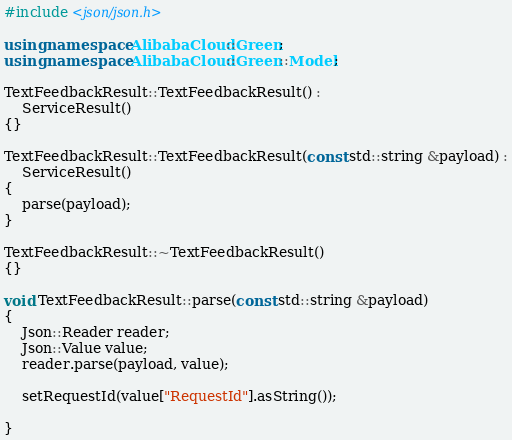<code> <loc_0><loc_0><loc_500><loc_500><_C++_>#include <json/json.h>

using namespace AlibabaCloud::Green;
using namespace AlibabaCloud::Green::Model;

TextFeedbackResult::TextFeedbackResult() :
	ServiceResult()
{}

TextFeedbackResult::TextFeedbackResult(const std::string &payload) :
	ServiceResult()
{
	parse(payload);
}

TextFeedbackResult::~TextFeedbackResult()
{}

void TextFeedbackResult::parse(const std::string &payload)
{
	Json::Reader reader;
	Json::Value value;
	reader.parse(payload, value);

	setRequestId(value["RequestId"].asString());

}

</code> 